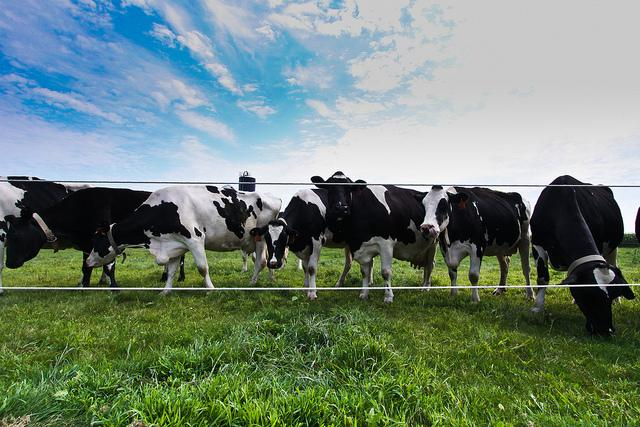What type of fence is shown here? wire fence 